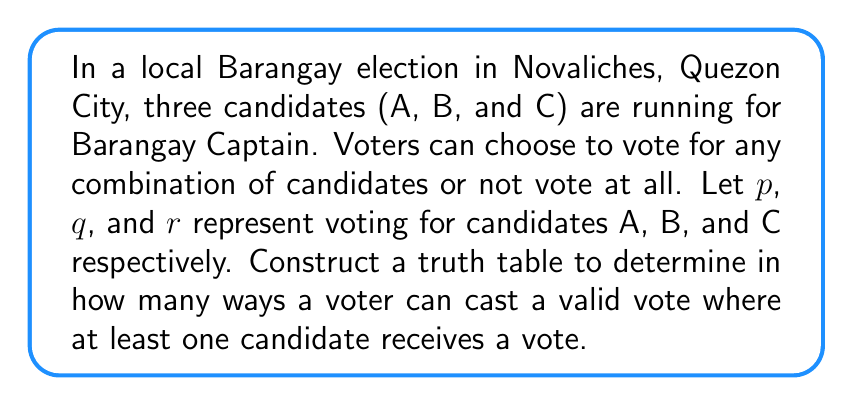Can you solve this math problem? Let's approach this step-by-step:

1) First, we need to create a truth table with all possible combinations of voting for the three candidates:

   $p$ | $q$ | $r$ | Valid Vote
   ---|---|---|---
   0 | 0 | 0 | No
   0 | 0 | 1 | Yes
   0 | 1 | 0 | Yes
   0 | 1 | 1 | Yes
   1 | 0 | 0 | Yes
   1 | 0 | 1 | Yes
   1 | 1 | 0 | Yes
   1 | 1 | 1 | Yes

   Where 1 represents voting for a candidate and 0 represents not voting for that candidate.

2) The condition "at least one candidate receives a vote" can be represented by the Boolean expression:

   $$(p \lor q \lor r)$$

3) Looking at the truth table, we can see that this condition is true for all rows except the first one (0,0,0).

4) Therefore, out of the 8 possible combinations, 7 represent valid voting patterns where at least one candidate receives a vote.

5) These 7 valid voting patterns are:
   - Vote only for C (0,0,1)
   - Vote only for B (0,1,0)
   - Vote for B and C (0,1,1)
   - Vote only for A (1,0,0)
   - Vote for A and C (1,0,1)
   - Vote for A and B (1,1,0)
   - Vote for all three candidates (1,1,1)
Answer: 7 ways 